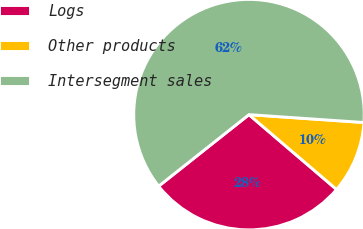Convert chart to OTSL. <chart><loc_0><loc_0><loc_500><loc_500><pie_chart><fcel>Logs<fcel>Other products<fcel>Intersegment sales<nl><fcel>28.09%<fcel>10.16%<fcel>61.75%<nl></chart> 